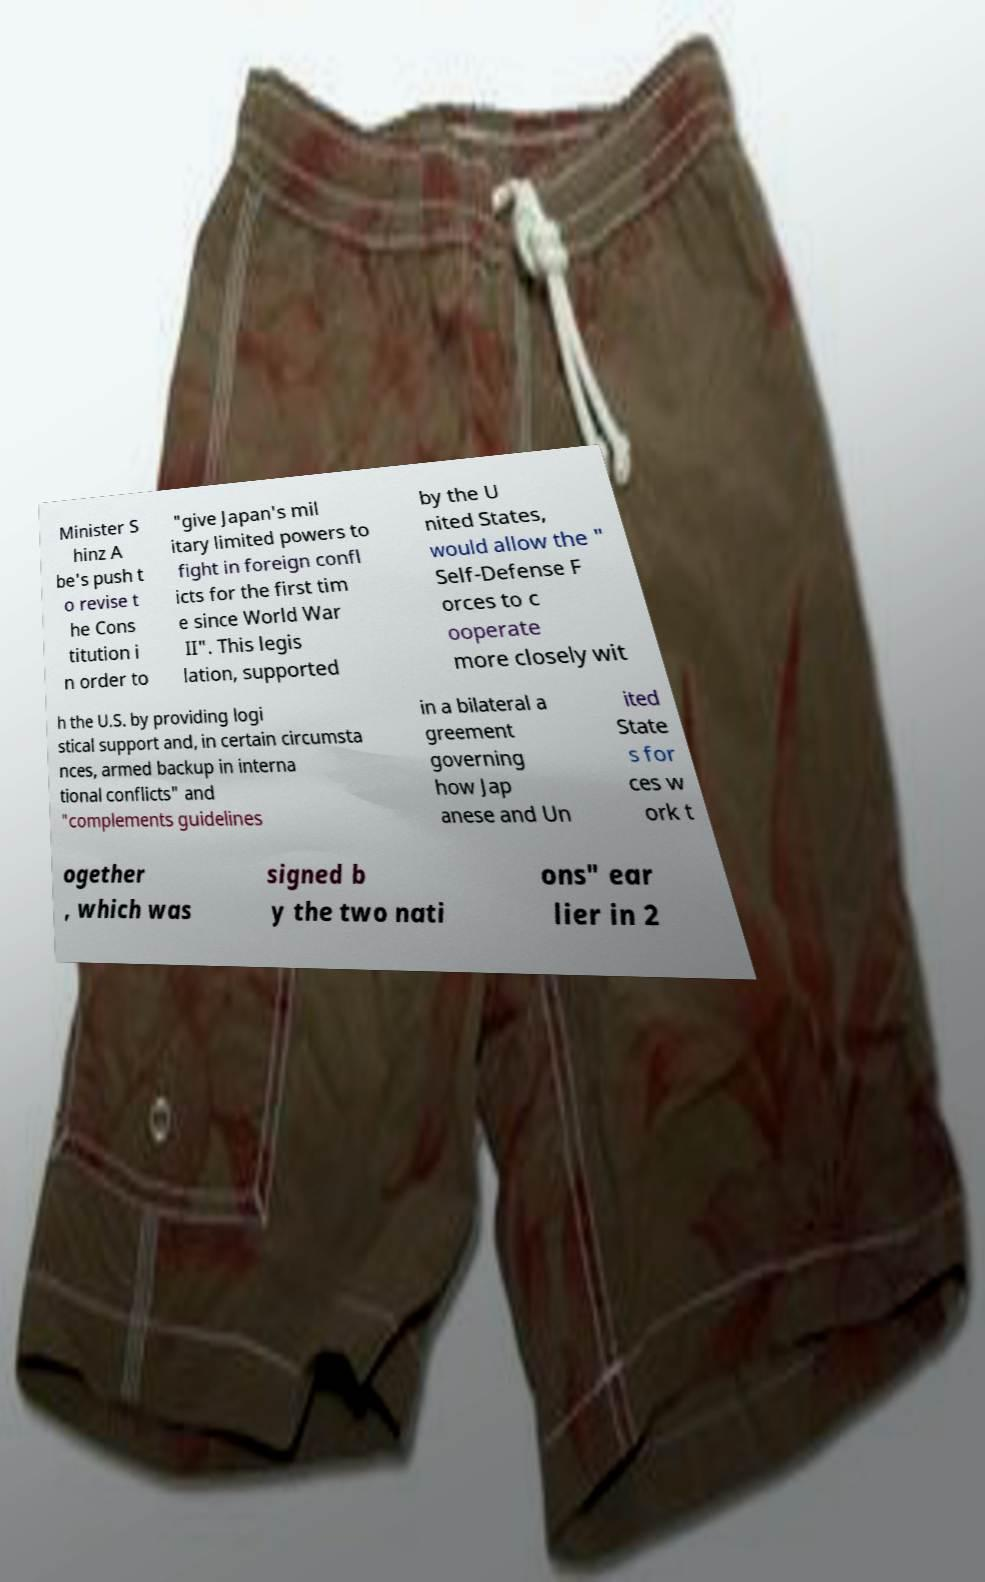Can you read and provide the text displayed in the image?This photo seems to have some interesting text. Can you extract and type it out for me? Minister S hinz A be's push t o revise t he Cons titution i n order to "give Japan's mil itary limited powers to fight in foreign confl icts for the first tim e since World War II". This legis lation, supported by the U nited States, would allow the " Self-Defense F orces to c ooperate more closely wit h the U.S. by providing logi stical support and, in certain circumsta nces, armed backup in interna tional conflicts" and "complements guidelines in a bilateral a greement governing how Jap anese and Un ited State s for ces w ork t ogether , which was signed b y the two nati ons" ear lier in 2 